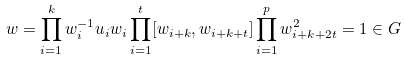Convert formula to latex. <formula><loc_0><loc_0><loc_500><loc_500>w = \prod _ { i = 1 } ^ { k } w _ { i } ^ { - 1 } u _ { i } w _ { i } \prod _ { i = 1 } ^ { t } [ w _ { i + k } , w _ { i + k + t } ] \prod _ { i = 1 } ^ { p } w _ { i + k + 2 t } ^ { 2 } = 1 \in G</formula> 